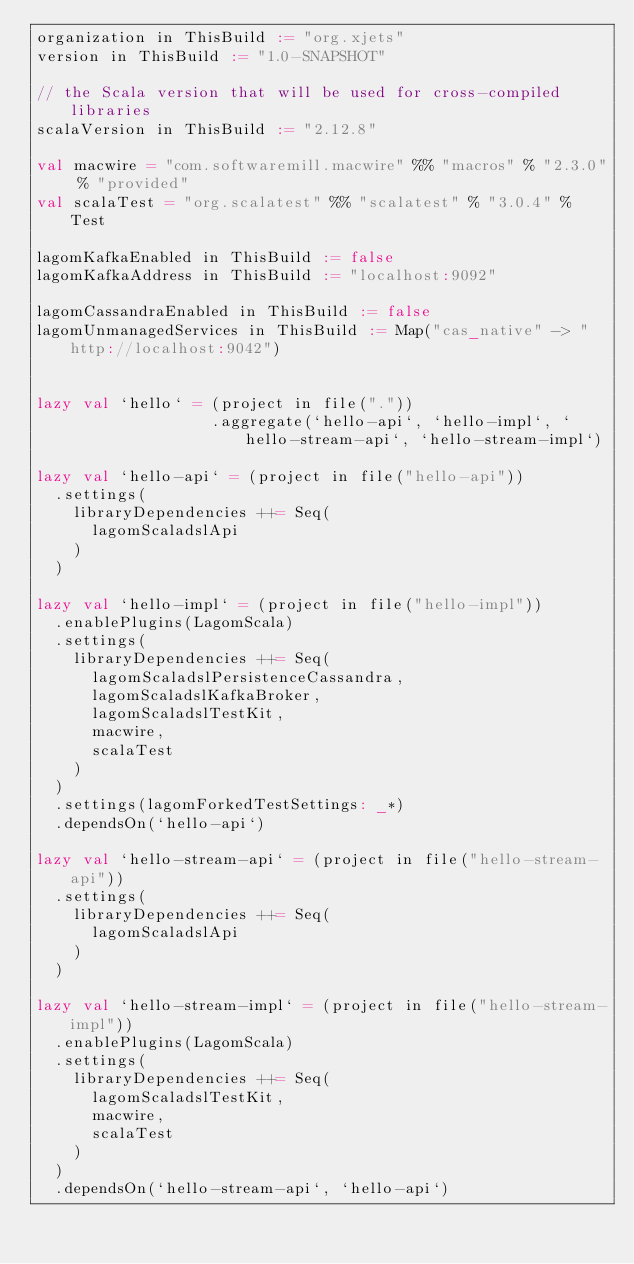<code> <loc_0><loc_0><loc_500><loc_500><_Scala_>organization in ThisBuild := "org.xjets"
version in ThisBuild := "1.0-SNAPSHOT"

// the Scala version that will be used for cross-compiled libraries
scalaVersion in ThisBuild := "2.12.8"

val macwire = "com.softwaremill.macwire" %% "macros" % "2.3.0" % "provided"
val scalaTest = "org.scalatest" %% "scalatest" % "3.0.4" % Test

lagomKafkaEnabled in ThisBuild := false
lagomKafkaAddress in ThisBuild := "localhost:9092"

lagomCassandraEnabled in ThisBuild := false
lagomUnmanagedServices in ThisBuild := Map("cas_native" -> "http://localhost:9042")
                                           

lazy val `hello` = (project in file("."))
                   .aggregate(`hello-api`, `hello-impl`, `hello-stream-api`, `hello-stream-impl`)

lazy val `hello-api` = (project in file("hello-api"))
  .settings(
    libraryDependencies ++= Seq(
      lagomScaladslApi
    )
  )

lazy val `hello-impl` = (project in file("hello-impl"))
  .enablePlugins(LagomScala)
  .settings(
    libraryDependencies ++= Seq(
      lagomScaladslPersistenceCassandra,
      lagomScaladslKafkaBroker,
      lagomScaladslTestKit,
      macwire,
      scalaTest
    )
  )
  .settings(lagomForkedTestSettings: _*)
  .dependsOn(`hello-api`)

lazy val `hello-stream-api` = (project in file("hello-stream-api"))
  .settings(
    libraryDependencies ++= Seq(
      lagomScaladslApi
    )
  )

lazy val `hello-stream-impl` = (project in file("hello-stream-impl"))
  .enablePlugins(LagomScala)
  .settings(
    libraryDependencies ++= Seq(
      lagomScaladslTestKit,
      macwire,
      scalaTest
    )
  )
  .dependsOn(`hello-stream-api`, `hello-api`)
</code> 